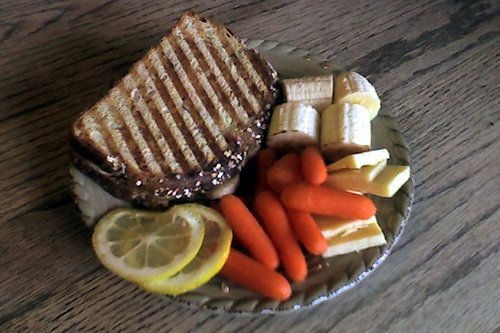Describe the objects in this image and their specific colors. I can see sandwich in black, maroon, and gray tones, banana in black, white, olive, and tan tones, orange in black, olive, and tan tones, orange in black, tan, olive, and maroon tones, and carrot in black, red, brown, and maroon tones in this image. 